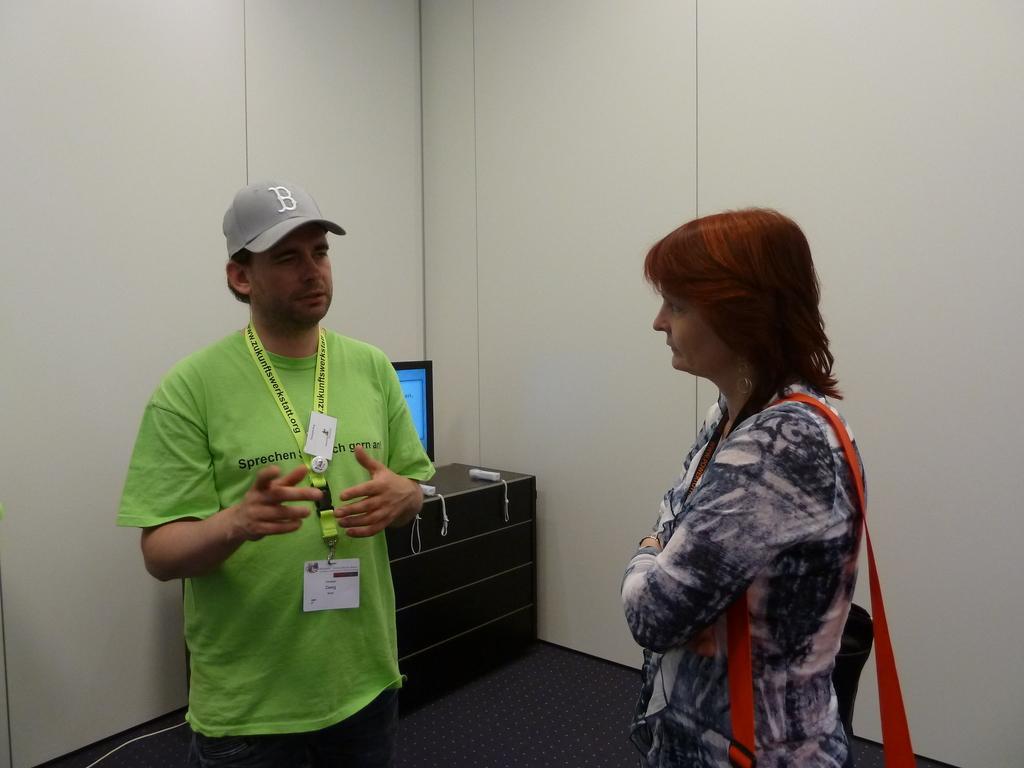Please provide a concise description of this image. In the picture I can see a man wearing green color T-shirt, identity card and cap is standing on the left side of the image and on the right side of the image we can see a woman wearing a dress and carrying a bag is standing. In the background, we can see the monitor is placed on the black color table and we can see the wall. 